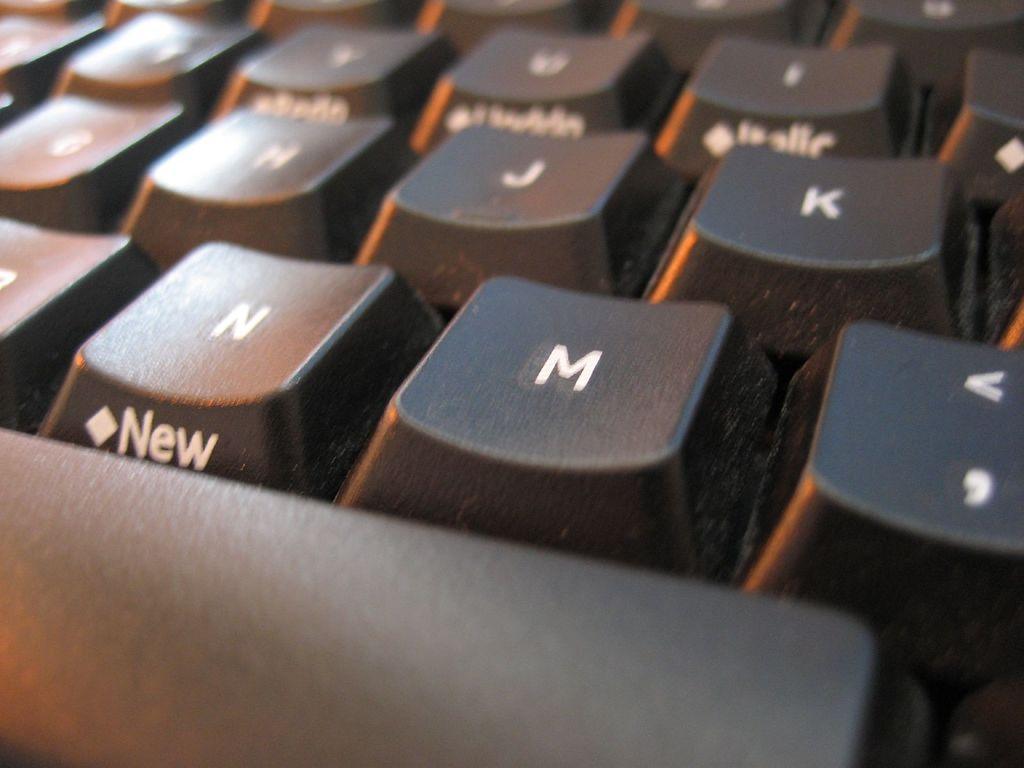How would you summarize this image in a sentence or two? In this image I can see the keyboard. On the keyboard there are alphabets on the buttons. And there is a name new on one of the button. 